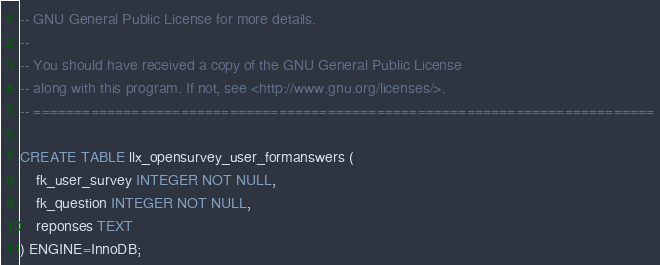<code> <loc_0><loc_0><loc_500><loc_500><_SQL_>-- GNU General Public License for more details.
--
-- You should have received a copy of the GNU General Public License
-- along with this program. If not, see <http://www.gnu.org/licenses/>.
-- ============================================================================

CREATE TABLE llx_opensurvey_user_formanswers (
    fk_user_survey INTEGER NOT NULL,
    fk_question INTEGER NOT NULL,
    reponses TEXT
) ENGINE=InnoDB;
</code> 